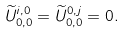<formula> <loc_0><loc_0><loc_500><loc_500>\widetilde { U } _ { 0 , 0 } ^ { i , 0 } = \widetilde { U } _ { 0 , 0 } ^ { 0 , j } = 0 .</formula> 